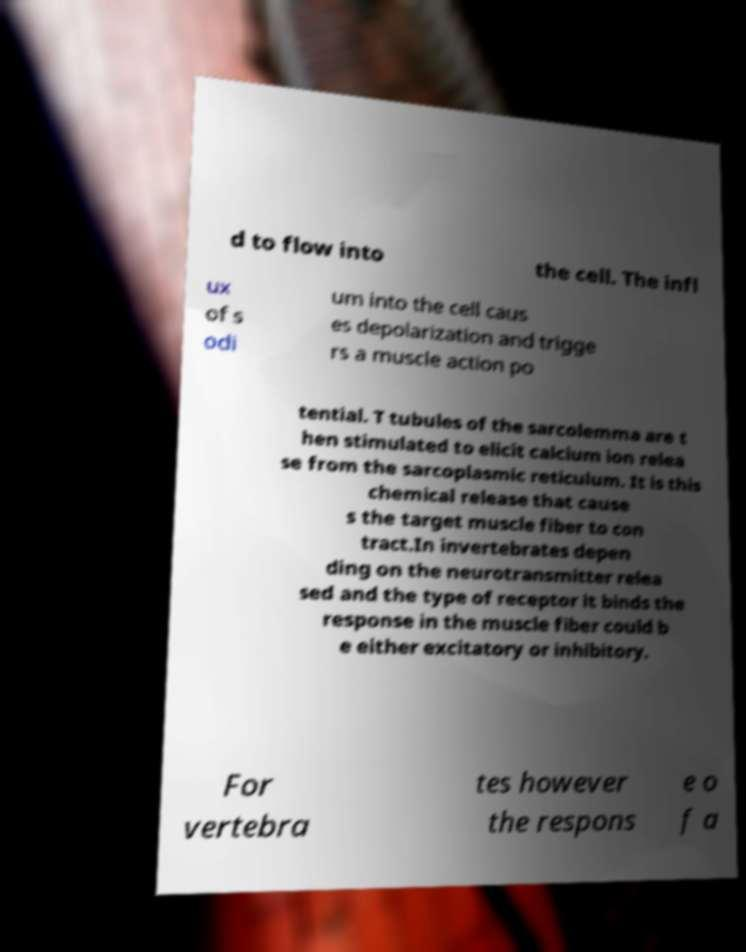Please read and relay the text visible in this image. What does it say? d to flow into the cell. The infl ux of s odi um into the cell caus es depolarization and trigge rs a muscle action po tential. T tubules of the sarcolemma are t hen stimulated to elicit calcium ion relea se from the sarcoplasmic reticulum. It is this chemical release that cause s the target muscle fiber to con tract.In invertebrates depen ding on the neurotransmitter relea sed and the type of receptor it binds the response in the muscle fiber could b e either excitatory or inhibitory. For vertebra tes however the respons e o f a 